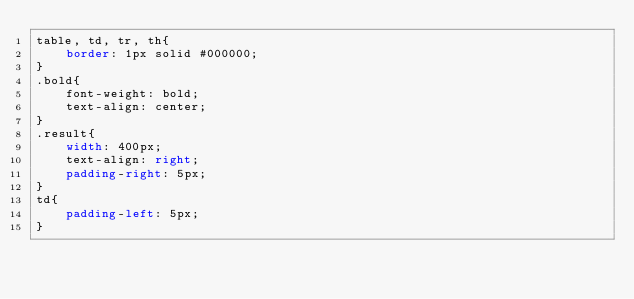Convert code to text. <code><loc_0><loc_0><loc_500><loc_500><_CSS_>table, td, tr, th{
    border: 1px solid #000000;
}
.bold{
    font-weight: bold;
    text-align: center;
}
.result{
    width: 400px;
    text-align: right;
    padding-right: 5px;
}
td{
    padding-left: 5px;
}
</code> 